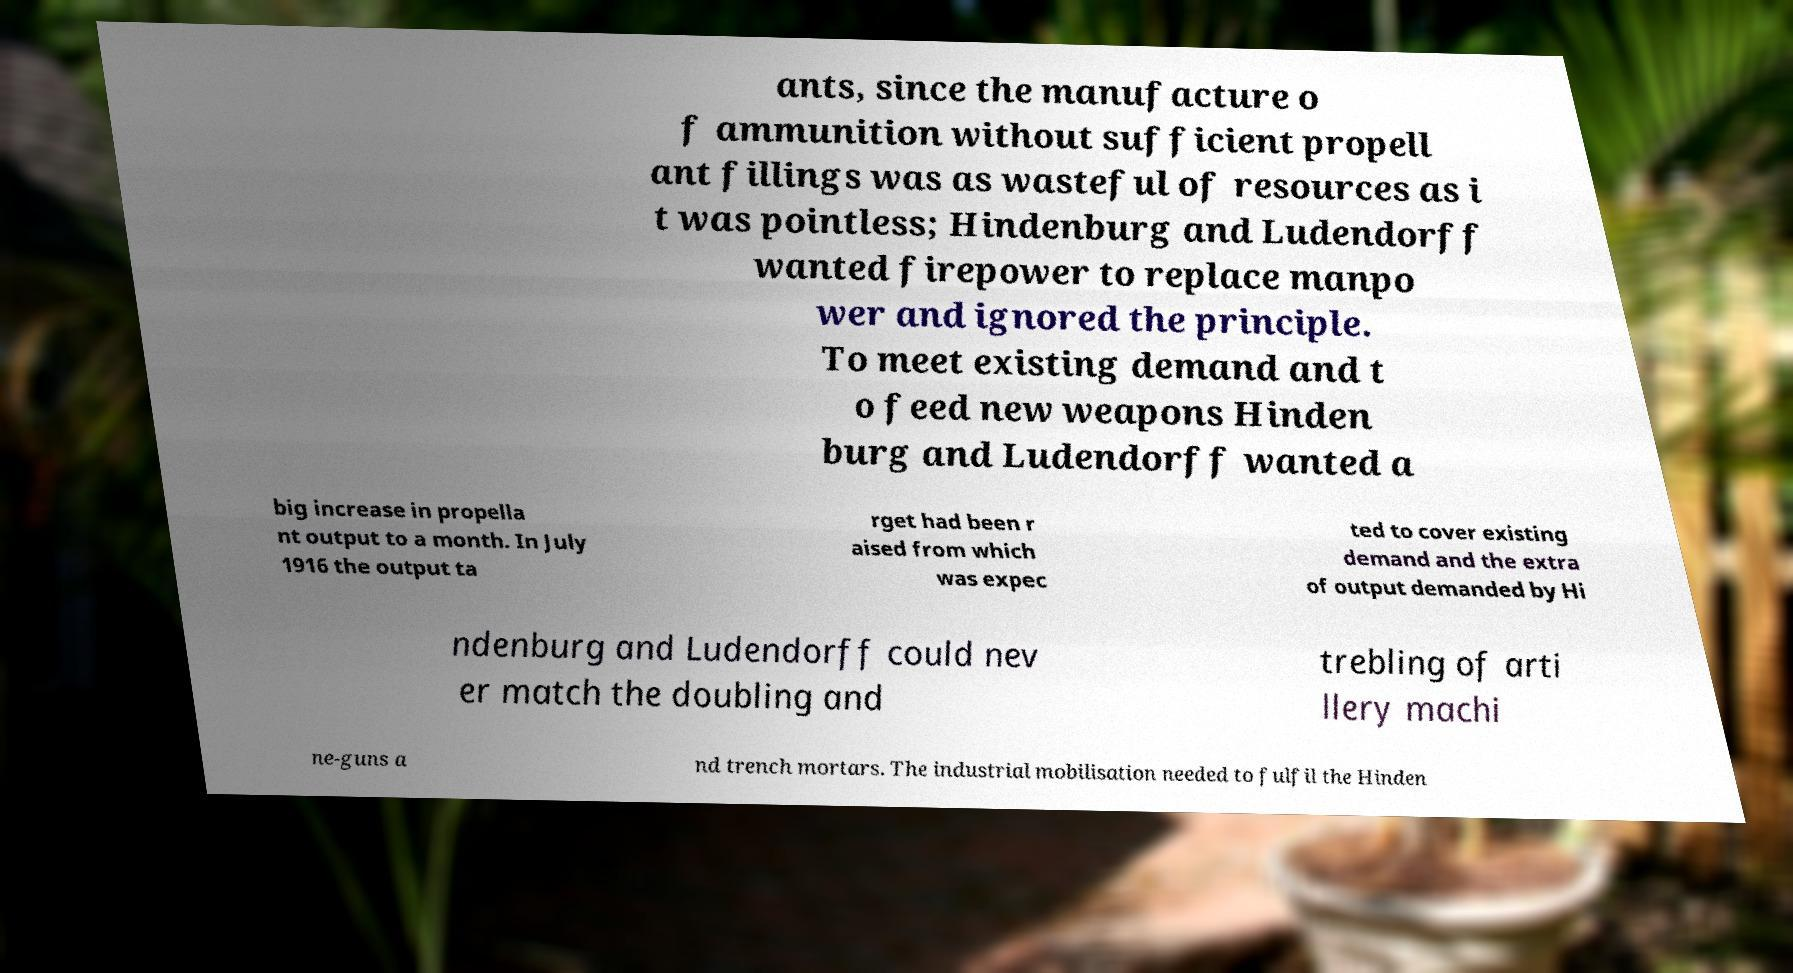Please read and relay the text visible in this image. What does it say? ants, since the manufacture o f ammunition without sufficient propell ant fillings was as wasteful of resources as i t was pointless; Hindenburg and Ludendorff wanted firepower to replace manpo wer and ignored the principle. To meet existing demand and t o feed new weapons Hinden burg and Ludendorff wanted a big increase in propella nt output to a month. In July 1916 the output ta rget had been r aised from which was expec ted to cover existing demand and the extra of output demanded by Hi ndenburg and Ludendorff could nev er match the doubling and trebling of arti llery machi ne-guns a nd trench mortars. The industrial mobilisation needed to fulfil the Hinden 